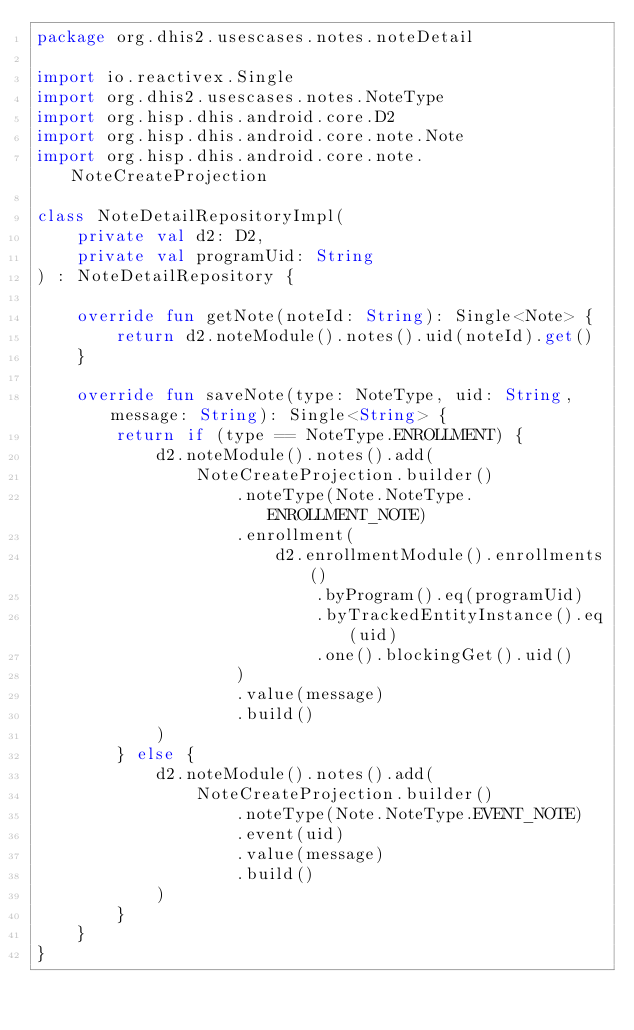Convert code to text. <code><loc_0><loc_0><loc_500><loc_500><_Kotlin_>package org.dhis2.usescases.notes.noteDetail

import io.reactivex.Single
import org.dhis2.usescases.notes.NoteType
import org.hisp.dhis.android.core.D2
import org.hisp.dhis.android.core.note.Note
import org.hisp.dhis.android.core.note.NoteCreateProjection

class NoteDetailRepositoryImpl(
    private val d2: D2,
    private val programUid: String
) : NoteDetailRepository {

    override fun getNote(noteId: String): Single<Note> {
        return d2.noteModule().notes().uid(noteId).get()
    }

    override fun saveNote(type: NoteType, uid: String, message: String): Single<String> {
        return if (type == NoteType.ENROLLMENT) {
            d2.noteModule().notes().add(
                NoteCreateProjection.builder()
                    .noteType(Note.NoteType.ENROLLMENT_NOTE)
                    .enrollment(
                        d2.enrollmentModule().enrollments()
                            .byProgram().eq(programUid)
                            .byTrackedEntityInstance().eq(uid)
                            .one().blockingGet().uid()
                    )
                    .value(message)
                    .build()
            )
        } else {
            d2.noteModule().notes().add(
                NoteCreateProjection.builder()
                    .noteType(Note.NoteType.EVENT_NOTE)
                    .event(uid)
                    .value(message)
                    .build()
            )
        }
    }
}
</code> 